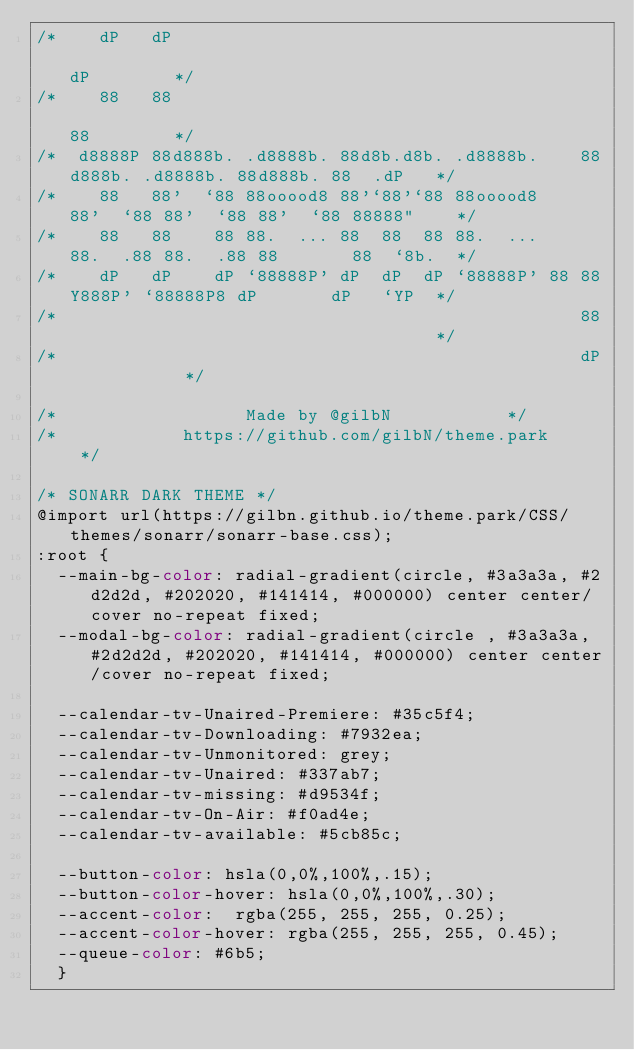Convert code to text. <code><loc_0><loc_0><loc_500><loc_500><_CSS_>/*    dP   dP                                                                  dP        */
/*    88   88                                                                  88        */
/*  d8888P 88d888b. .d8888b. 88d8b.d8b. .d8888b.    88d888b. .d8888b. 88d888b. 88  .dP   */
/*    88   88'  `88 88ooood8 88'`88'`88 88ooood8    88'  `88 88'  `88 88'  `88 88888"    */
/*    88   88    88 88.  ... 88  88  88 88.  ...    88.  .88 88.  .88 88       88  `8b.  */
/*    dP   dP    dP `88888P' dP  dP  dP `88888P' 88 88Y888P' `88888P8 dP       dP   `YP  */
/*                                                  88                                   */
/*                                                  dP					 */

/*		   		        Made by @gilbN					 */
/*			      https://github.com/gilbN/theme.park			 */

/* SONARR DARK THEME */
@import url(https://gilbn.github.io/theme.park/CSS/themes/sonarr/sonarr-base.css);
:root {
  --main-bg-color: radial-gradient(circle, #3a3a3a, #2d2d2d, #202020, #141414, #000000) center center/cover no-repeat fixed;
  --modal-bg-color: radial-gradient(circle , #3a3a3a, #2d2d2d, #202020, #141414, #000000) center center/cover no-repeat fixed;

  --calendar-tv-Unaired-Premiere: #35c5f4;
  --calendar-tv-Downloading: #7932ea; 
  --calendar-tv-Unmonitored: grey;
  --calendar-tv-Unaired: #337ab7;  
  --calendar-tv-missing: #d9534f;
  --calendar-tv-On-Air: #f0ad4e; 
  --calendar-tv-available: #5cb85c;

  --button-color: hsla(0,0%,100%,.15);
  --button-color-hover: hsla(0,0%,100%,.30);
  --accent-color:  rgba(255, 255, 255, 0.25);
  --accent-color-hover: rgba(255, 255, 255, 0.45);
  --queue-color: #6b5;
  }</code> 